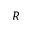<formula> <loc_0><loc_0><loc_500><loc_500>R</formula> 